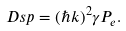Convert formula to latex. <formula><loc_0><loc_0><loc_500><loc_500>\ D s p = ( \hslash k ) ^ { 2 } \gamma P _ { e } .</formula> 